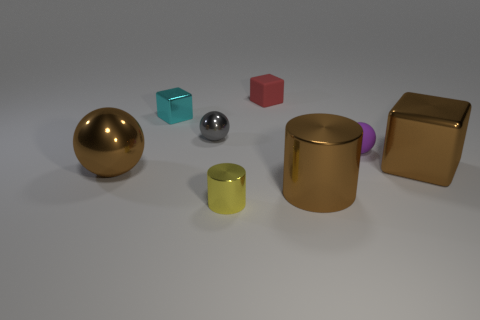There is a ball that is the same color as the big cylinder; what material is it?
Keep it short and to the point. Metal. There is a metal cylinder right of the tiny red matte cube; is there a cube to the right of it?
Provide a short and direct response. Yes. Is the shape of the red object the same as the cyan shiny object?
Give a very brief answer. Yes. There is a cyan object that is made of the same material as the small yellow cylinder; what is its shape?
Offer a terse response. Cube. There is a metallic cylinder that is left of the red cube; is its size the same as the metallic block that is left of the small shiny cylinder?
Provide a succinct answer. Yes. Are there more metallic balls left of the big metal cylinder than large brown metal spheres that are behind the cyan metal cube?
Your response must be concise. Yes. What number of other things are the same color as the large shiny sphere?
Your answer should be compact. 2. Does the tiny metallic block have the same color as the tiny metallic thing in front of the large brown shiny block?
Ensure brevity in your answer.  No. There is a metallic thing in front of the large brown metal cylinder; what number of big metallic things are behind it?
Ensure brevity in your answer.  3. What material is the large brown thing behind the big brown metallic thing on the left side of the sphere that is behind the matte ball made of?
Provide a succinct answer. Metal. 